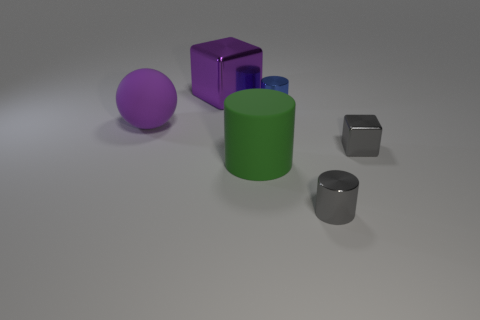There is a gray object that is the same shape as the large green rubber thing; what is its size?
Give a very brief answer. Small. Is the number of metal blocks that are on the right side of the small gray cylinder the same as the number of rubber spheres that are right of the large green cylinder?
Keep it short and to the point. No. What number of other objects are there of the same material as the large purple ball?
Offer a very short reply. 1. Is the number of gray shiny cubes in front of the large green rubber object the same as the number of small yellow objects?
Give a very brief answer. Yes. Do the purple block and the purple object on the left side of the large metal object have the same size?
Provide a succinct answer. Yes. There is a large thing behind the tiny blue thing; what is its shape?
Your response must be concise. Cube. Is there anything else that is the same shape as the green thing?
Give a very brief answer. Yes. Are any tiny yellow metallic cylinders visible?
Ensure brevity in your answer.  No. There is a metal block that is right of the purple shiny block; is it the same size as the metallic cube that is on the left side of the tiny blue cylinder?
Offer a very short reply. No. What is the big thing that is in front of the large shiny object and on the right side of the big ball made of?
Offer a very short reply. Rubber. 